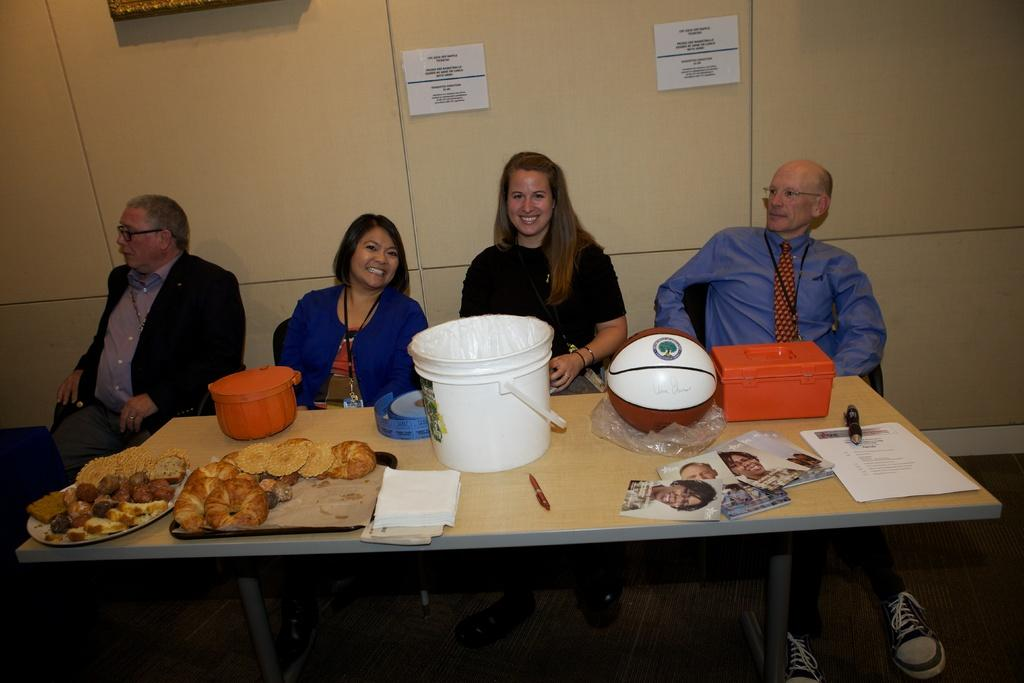How many people are in the image? There is a group of people in the image. What are the people doing in the image? The people are sitting on chairs. Where are the chairs located in relation to the table? The chairs are in front of a table. What can be found on the table in the image? There are objects on the table. Is it raining in the image? There is no indication of rain in the image. Can you see any stitches on the people's clothing in the image? The provided facts do not mention any details about the people's clothing, so it is impossible to determine if there are any stitches visible. 